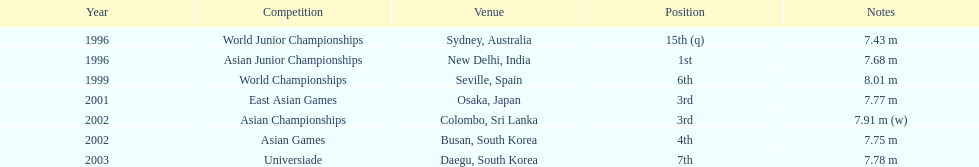Tell me the only venue in spain. Seville, Spain. 